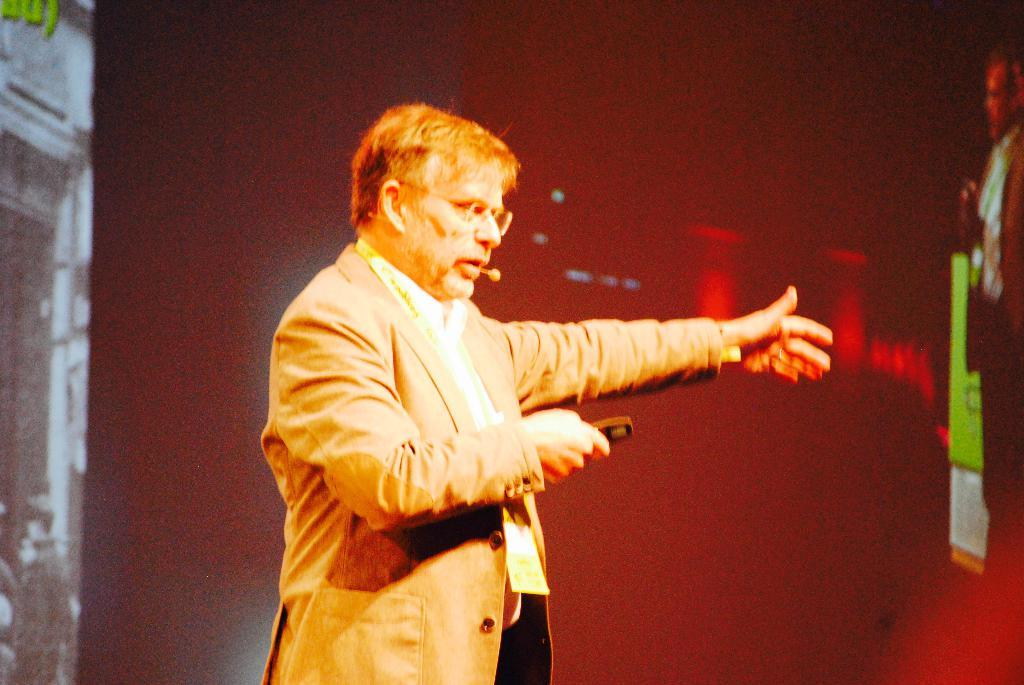What is the main subject of the image? There is a person in the image. What is the person holding in his hand? The person is holding a remote in his hand. What device is the person wearing on his ear? The person is wearing a microphone on his ear. What is the person doing in the image? The person appears to be talking. What can be seen in the background of the image? There are lights visible in the image. Are there any other objects present in the image besides the person? Yes, there are other objects present in the image. What type of bath can be seen in the image? There is no bath present in the image. What activity are the snails participating in within the image? There are no snails present in the image, so no such activity can be observed. 